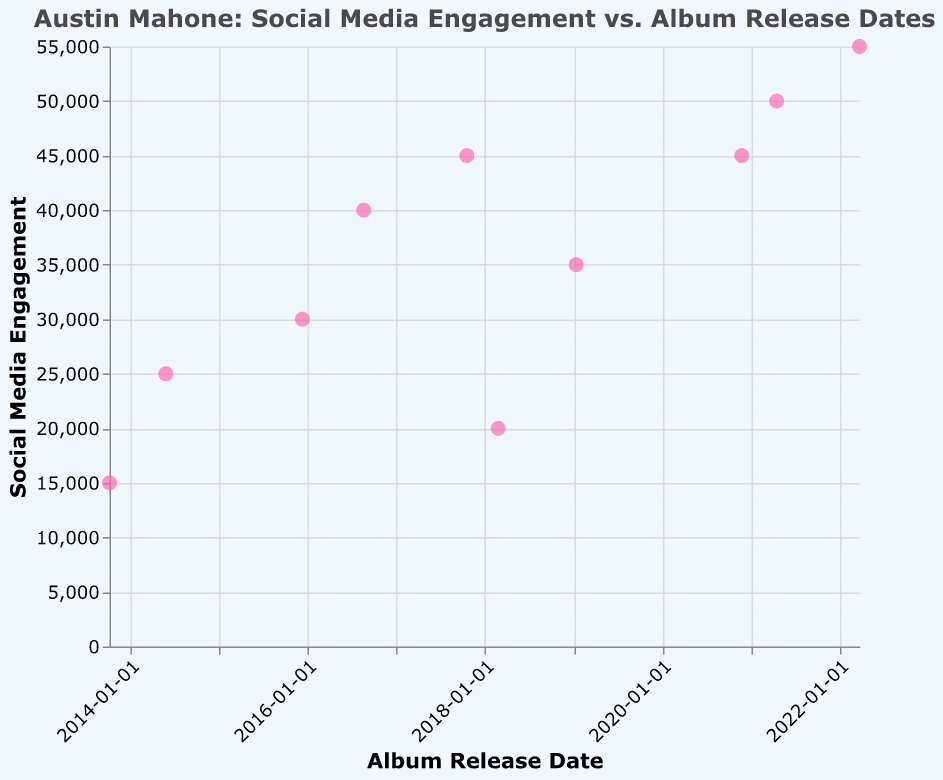How many data points are shown in the scatter plot? Count the number of points displayed on the scatter plot. There are 10 data points for 10 release dates.
Answer: 10 What color are the points representing Social Media Engagement? The points are filled with a color that looks pinkish. This is visible from the figure's visual presentation.
Answer: Pink Which year had the lowest social media engagement? Identify the point with the lowest y-value (Social Media Engagement) and read the corresponding x-value (Date). The lowest engagement (15000) is in 2013.
Answer: 2013 How much did the social media engagement increase from 2013 to 2014? Subtract the 2013 engagement value (15000) from the 2014 engagement value (25000).
Answer: 10000 What is the title of the scatter plot? Read the text at the top of the plot, which is clearly visible in the figure. The title is "Austin Mahone: Social Media Engagement vs. Album Release Dates".
Answer: Austin Mahone: Social Media Engagement vs. Album Release Dates What is the axis label for the y-axis? The y-axis label is the title explaining the data represented by the y-axis. It reads "Social Media Engagement".
Answer: Social Media Engagement During which period did social media engagement see the most significant increase? Compare consecutive points and measure the differences in their y-values. The most significant increase happens between April 16, 2021 (50000) and March 23, 2022 (55000), amounting to 5000.
Answer: 2021-2022 Which album release date had the highest social media engagement? Identify the point with the highest y-value. The highest engagement (55000) is on March 23, 2022.
Answer: March 23, 2022 What was the social media engagement on February 24, 2018? Locate the point corresponding to the release date "2018-02-24" and read its y-value. The engagement value is 20000.
Answer: 20000 What is the average social media engagement over these dates? Sum all engagement values (15000 + 25000 + 30000 + 40000 + 45000 + 20000 + 35000 + 45000 + 50000 + 55000 = 350000) and divide by the number of data points (10). The average is 350000 / 10.
Answer: 35000 